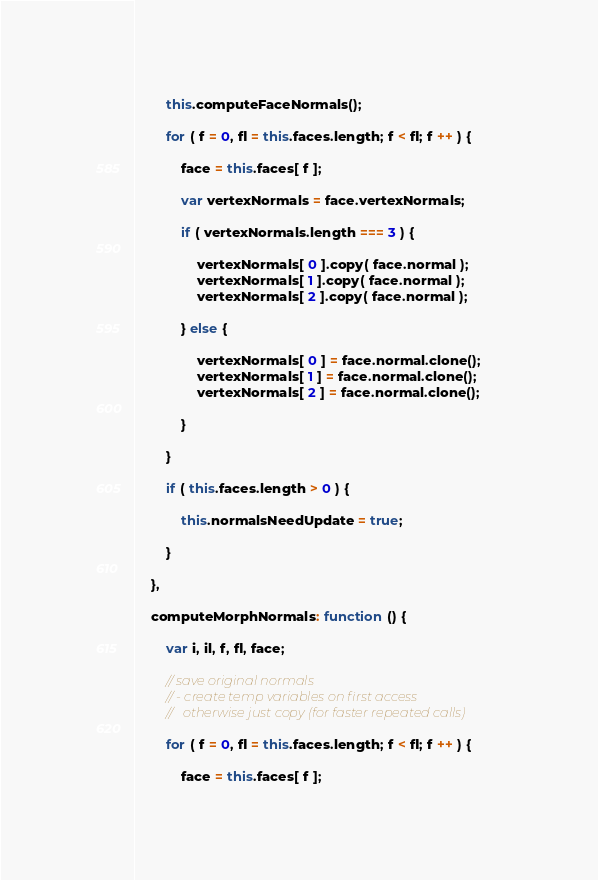<code> <loc_0><loc_0><loc_500><loc_500><_JavaScript_>		this.computeFaceNormals();

		for ( f = 0, fl = this.faces.length; f < fl; f ++ ) {

			face = this.faces[ f ];

			var vertexNormals = face.vertexNormals;

			if ( vertexNormals.length === 3 ) {

				vertexNormals[ 0 ].copy( face.normal );
				vertexNormals[ 1 ].copy( face.normal );
				vertexNormals[ 2 ].copy( face.normal );

			} else {

				vertexNormals[ 0 ] = face.normal.clone();
				vertexNormals[ 1 ] = face.normal.clone();
				vertexNormals[ 2 ] = face.normal.clone();

			}

		}

		if ( this.faces.length > 0 ) {

			this.normalsNeedUpdate = true;

		}

	},

	computeMorphNormals: function () {

		var i, il, f, fl, face;

		// save original normals
		// - create temp variables on first access
		//   otherwise just copy (for faster repeated calls)

		for ( f = 0, fl = this.faces.length; f < fl; f ++ ) {

			face = this.faces[ f ];
</code> 